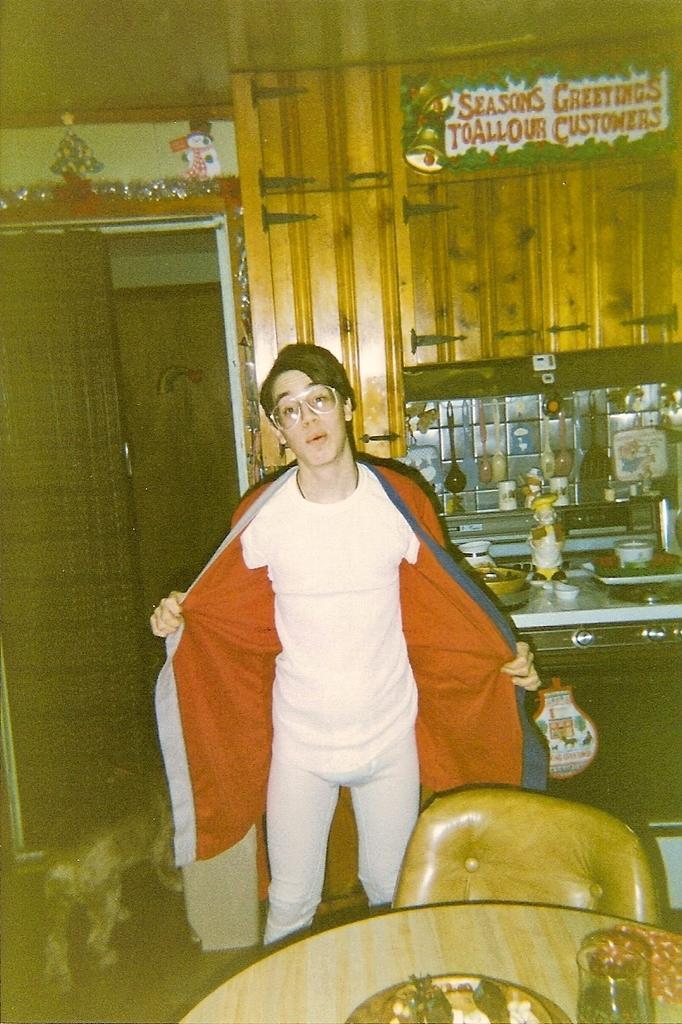Could you give a brief overview of what you see in this image? A boy is standing, he wore a white color dress. In the right side it is a table, chair. 